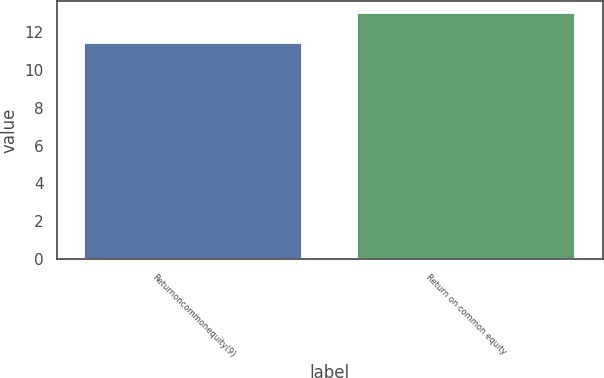<chart> <loc_0><loc_0><loc_500><loc_500><bar_chart><fcel>Returnoncommonequity(9)<fcel>Return on common equity<nl><fcel>11.4<fcel>13<nl></chart> 